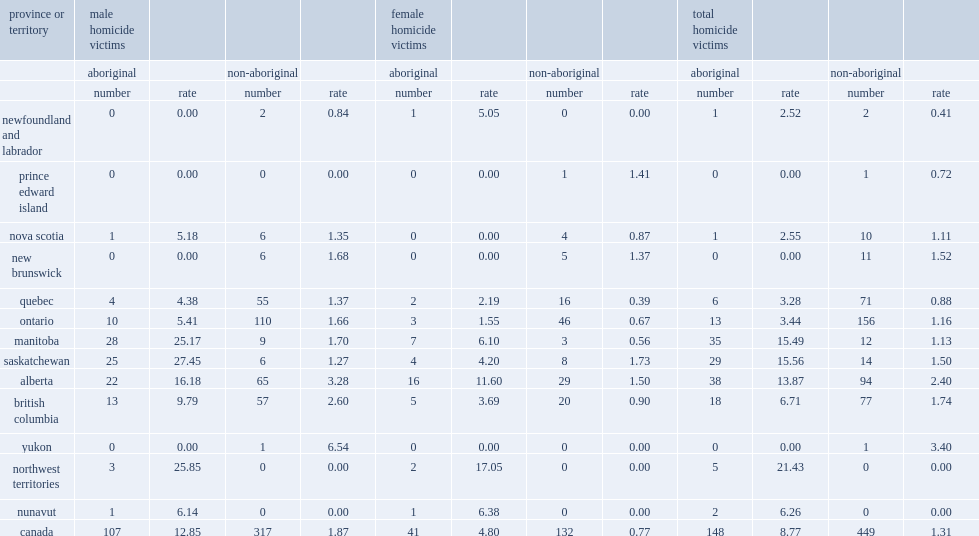Could you parse the entire table? {'header': ['province or territory', 'male homicide victims', '', '', '', 'female homicide victims', '', '', '', 'total homicide victims', '', '', ''], 'rows': [['', 'aboriginal', '', 'non-aboriginal', '', 'aboriginal', '', 'non-aboriginal', '', 'aboriginal', '', 'non-aboriginal', ''], ['', 'number', 'rate', 'number', 'rate', 'number', 'rate', 'number', 'rate', 'number', 'rate', 'number', 'rate'], ['newfoundland and labrador', '0', '0.00', '2', '0.84', '1', '5.05', '0', '0.00', '1', '2.52', '2', '0.41'], ['prince edward island', '0', '0.00', '0', '0.00', '0', '0.00', '1', '1.41', '0', '0.00', '1', '0.72'], ['nova scotia', '1', '5.18', '6', '1.35', '0', '0.00', '4', '0.87', '1', '2.55', '10', '1.11'], ['new brunswick', '0', '0.00', '6', '1.68', '0', '0.00', '5', '1.37', '0', '0.00', '11', '1.52'], ['quebec', '4', '4.38', '55', '1.37', '2', '2.19', '16', '0.39', '6', '3.28', '71', '0.88'], ['ontario', '10', '5.41', '110', '1.66', '3', '1.55', '46', '0.67', '13', '3.44', '156', '1.16'], ['manitoba', '28', '25.17', '9', '1.70', '7', '6.10', '3', '0.56', '35', '15.49', '12', '1.13'], ['saskatchewan', '25', '27.45', '6', '1.27', '4', '4.20', '8', '1.73', '29', '15.56', '14', '1.50'], ['alberta', '22', '16.18', '65', '3.28', '16', '11.60', '29', '1.50', '38', '13.87', '94', '2.40'], ['british columbia', '13', '9.79', '57', '2.60', '5', '3.69', '20', '0.90', '18', '6.71', '77', '1.74'], ['yukon', '0', '0.00', '1', '6.54', '0', '0.00', '0', '0.00', '0', '0.00', '1', '3.40'], ['northwest territories', '3', '25.85', '0', '0.00', '2', '17.05', '0', '0.00', '5', '21.43', '0', '0.00'], ['nunavut', '1', '6.14', '0', '0.00', '1', '6.38', '0', '0.00', '2', '6.26', '0', '0.00'], ['canada', '107', '12.85', '317', '1.87', '41', '4.80', '132', '0.77', '148', '8.77', '449', '1.31']]} What was the total number of aboriginal victims of homicide in 2015? 148.0. What was the rate of homicide for aboriginal people per 100,000 aboriginal people in 2015? 8.77. What was the rate of homicide for non-aboriginal people per 100,000 aboriginal people in 2015? 1.31. What was the multiple relationship between the rate of homicide for aboriginal people and for non-aboriginal people in 2015? 6.694656. Who were more frequently victims of homicide,aboriginal males or non-aboriginal males? Aboriginal. What was the multiple relationship between aboriginal males and non-aboriginal males of the rate of homicide in 2015? 6.871658. What was the multiple relationship between aboriginal males and aboriginal females of the rate of homicide in 2015? 2.677083. 